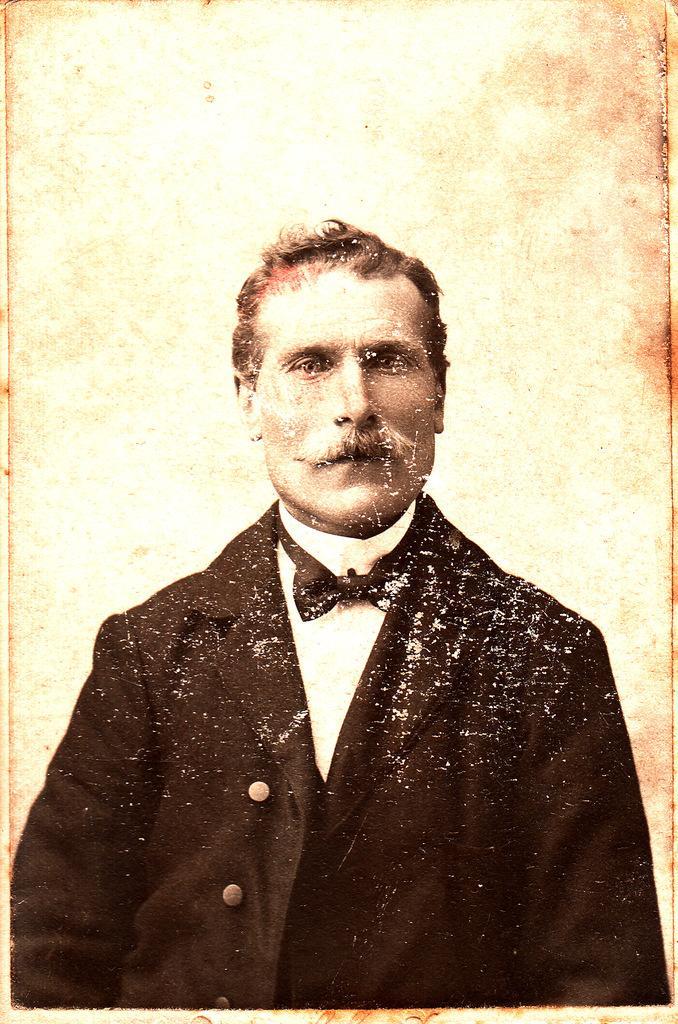How would you summarize this image in a sentence or two? In this picture we can see a person wearing a blazer and a bow tie. 